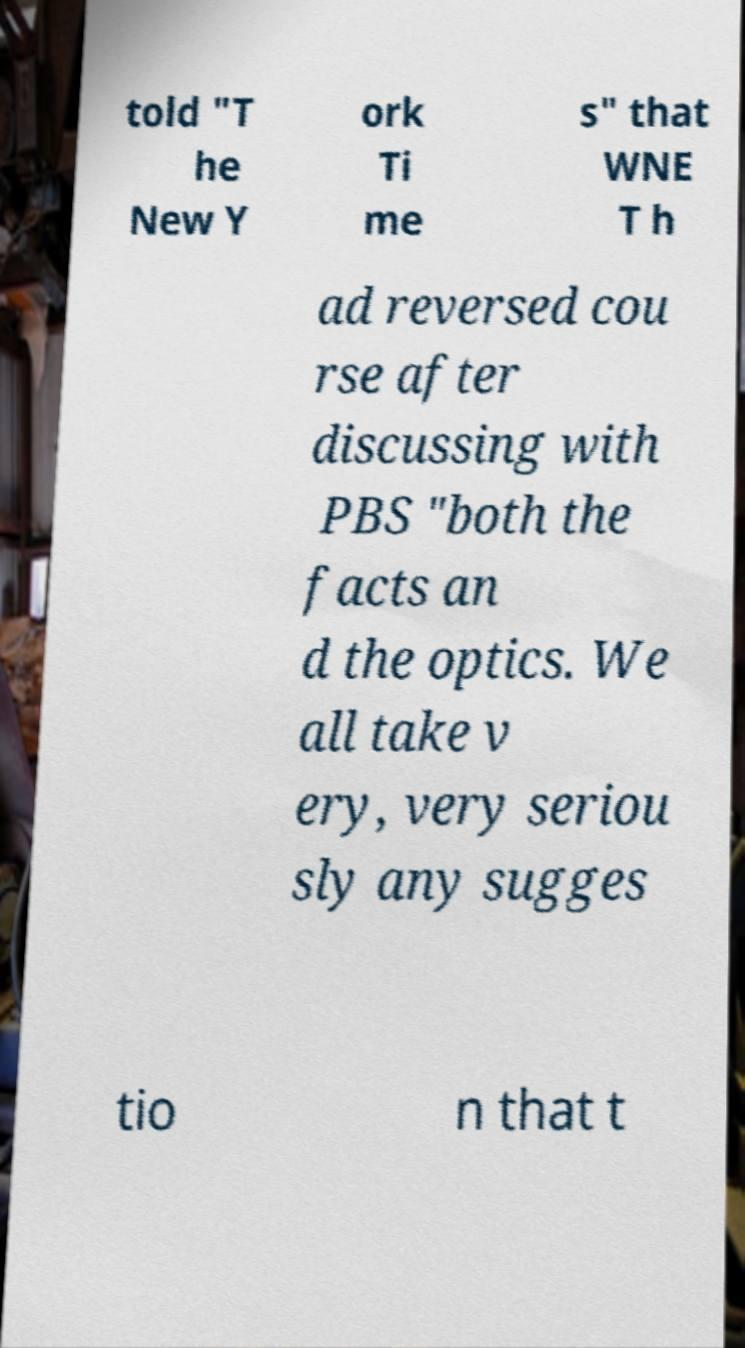Can you accurately transcribe the text from the provided image for me? told "T he New Y ork Ti me s" that WNE T h ad reversed cou rse after discussing with PBS "both the facts an d the optics. We all take v ery, very seriou sly any sugges tio n that t 